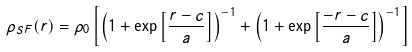<formula> <loc_0><loc_0><loc_500><loc_500>\rho _ { S F } ( r ) = \rho _ { 0 } \left [ \left ( 1 + \exp \left [ \frac { r - c } { a } \right ] \right ) ^ { - 1 } + \left ( 1 + \exp \left [ \frac { - r - c } { a } \right ] \right ) ^ { - 1 } \right ]</formula> 